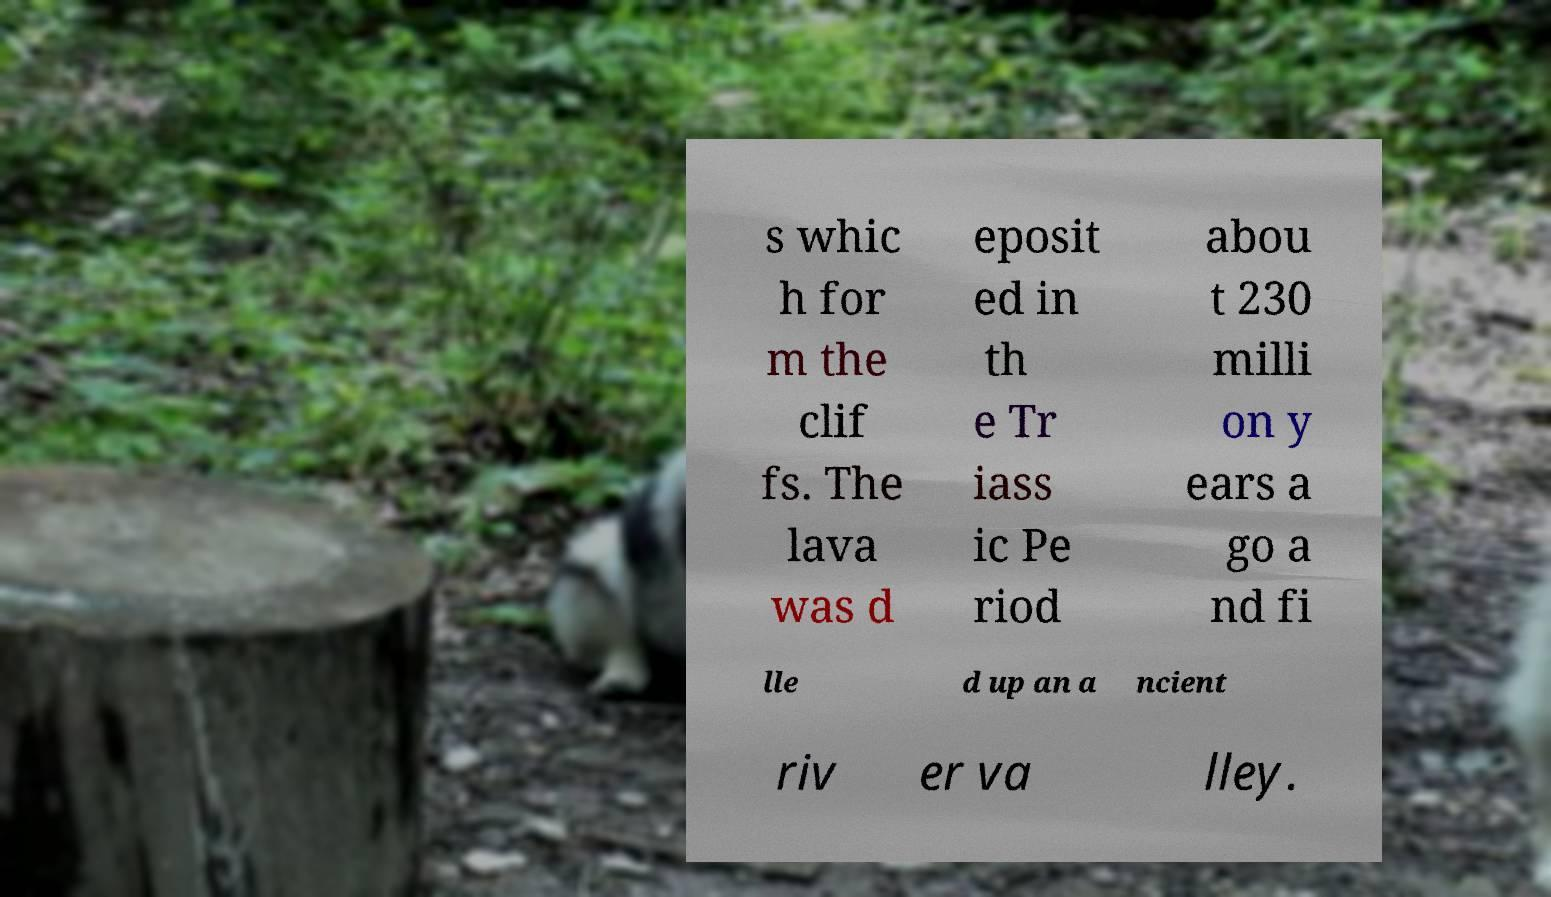There's text embedded in this image that I need extracted. Can you transcribe it verbatim? s whic h for m the clif fs. The lava was d eposit ed in th e Tr iass ic Pe riod abou t 230 milli on y ears a go a nd fi lle d up an a ncient riv er va lley. 